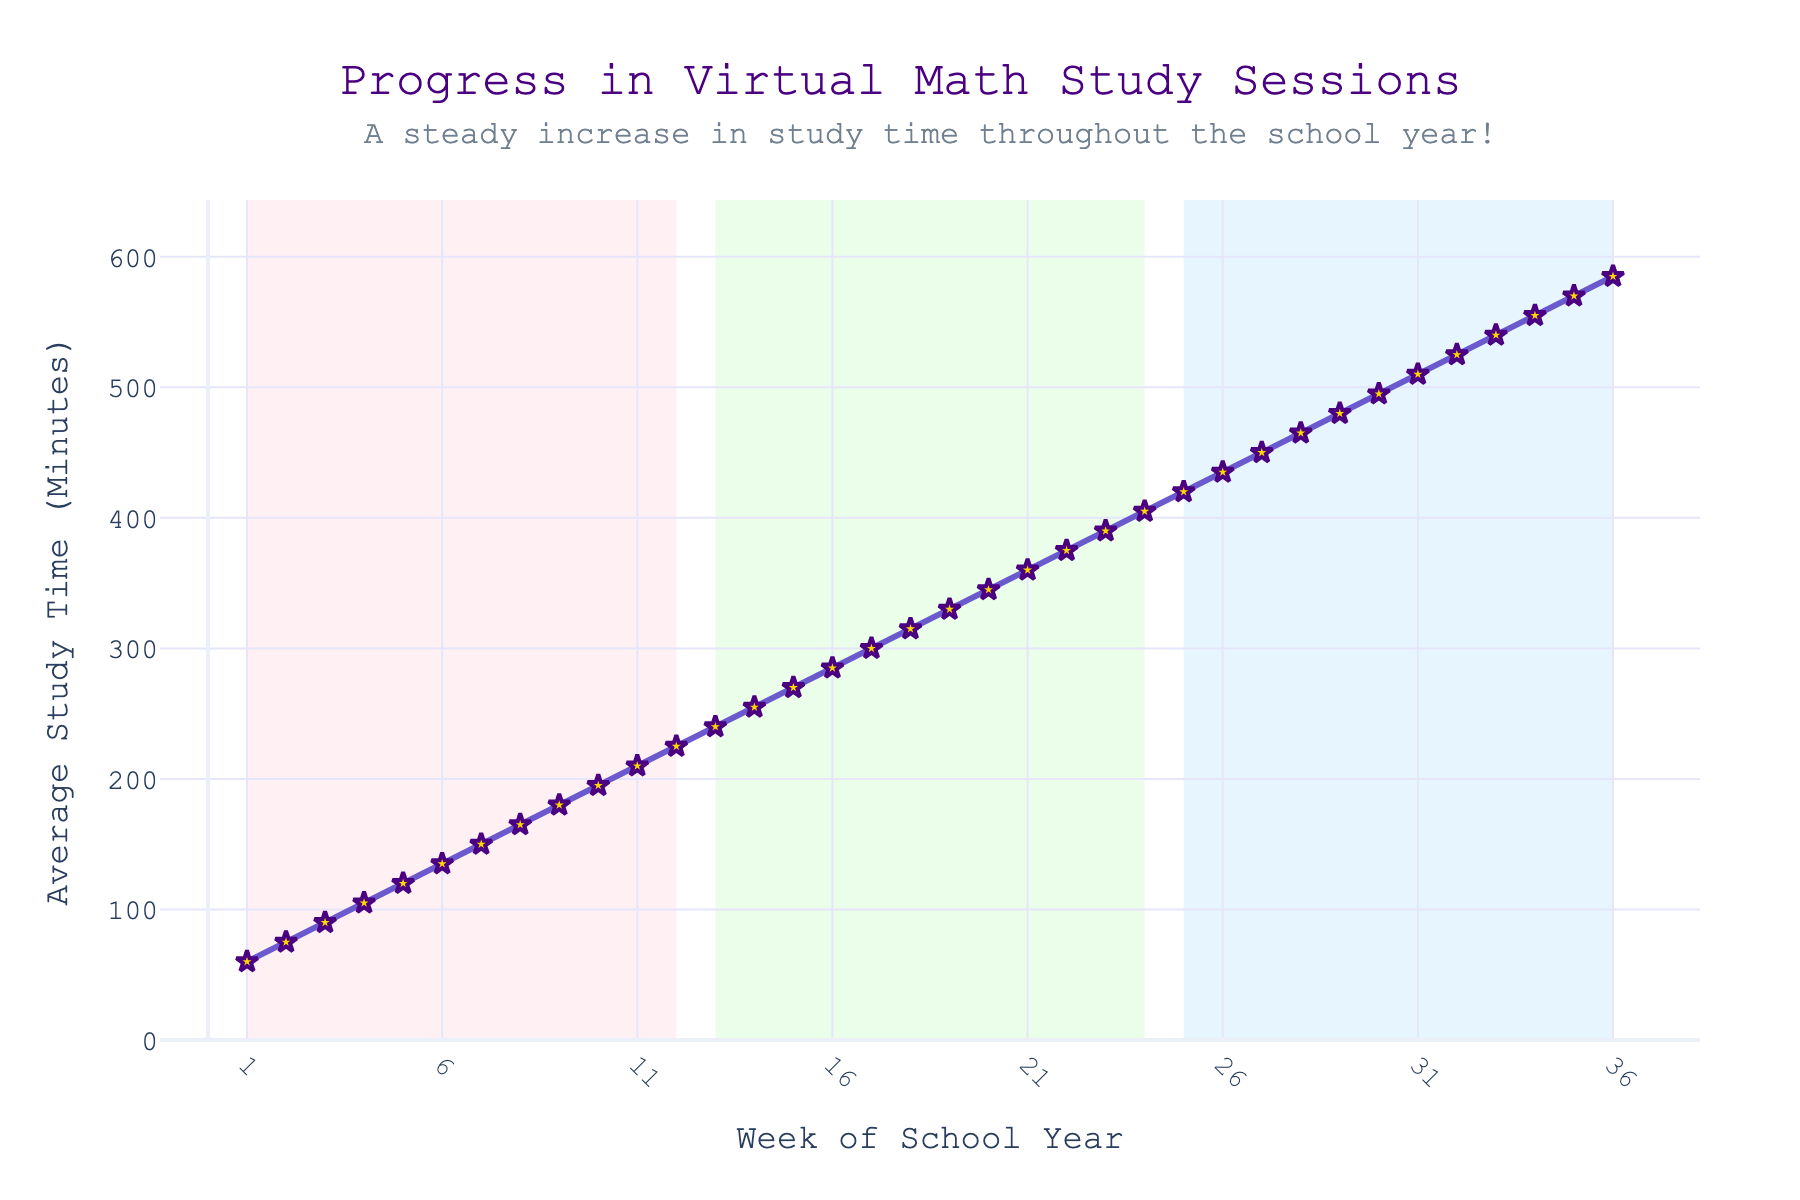How does the average study time change from Week 5 to Week 15? To find the change, subtract the average study time at Week 5 from the average study time at Week 15. The average study times are 120 minutes at Week 5 and 270 minutes at Week 15. The change is 270 - 120 = 150 minutes.
Answer: 150 minutes What is the average weekly increase in study time over the entire school year? To compute this, we need the total increase in study time and then divide by the number of weeks. The total increase is from 60 minutes (Week 1) to 585 minutes (Week 36), which is 585 - 60 = 525 minutes. The average weekly increase is 525 minutes / 35 weeks = 15 minutes/week.
Answer: 15 minutes/week Which period has the highest average study time: Weeks 1-12, Weeks 13-24, or Weeks 25-36? Calculate the average study time for each of these periods. Weeks 1-12: (60+75+90+105+120+135+150+165+180+195+210+225)/12 = 148.75 minutes; Weeks 13-24: (240+255+270+285+300+315+330+345+360+375+390+405)/12 = 317.5 minutes; Weeks 25-36: (420+435+450+465+480+495+510+525+540+555+570+585)/12 = 487.5 minutes. The highest average study time is in Weeks 25-36.
Answer: Weeks 25-36 Between which two consecutive weeks is the largest increase in average study time observed? To determine this, look at the changes between consecutive weeks. Calculate the differences: Week 2 - Week 1 = 15, Week 3 - Week 2 = 15, ..., Week 36 - Week 35 = 15. The differences are the same each week, so any consecutive weeks will have the same increase.
Answer: Any consecutive weeks Is the increase in average study time consistent throughout the school year? Based on the line chart, the increase appears to be consistent with the same slope throughout the school year, showing a steady, linear rise.
Answer: Yes In which portion of the school year (Weeks 1-12, Weeks 13-24, Weeks 25-36) is the study time increase the steepest? The rate of increase appears consistent throughout the chart, implying that the study time increase is even across all three portions when observed from the linear trend lines.
Answer: All portions equally What visual feature indicates the trend of average study time throughout the school year? The steady upward slope of the line and the star markers connected by lines indicate a consistent increase in average study time throughout the school year. The annotations and the line's color also help point out the trend.
Answer: steady upward slope How many weeks into the school year did the average study time exceed 300 minutes for the first time? Locate the point where the study time first exceeds 300 minutes. This happens at Week 17.
Answer: Week 17 Which week marks the halfway point of the data set and what is the average study time during that week? The data set has 36 weeks, so the halfway point is 36/2 = Week 18. At Week 18, the average study time is 315 minutes.
Answer: Week 18, 315 minutes What can be inferred from the shaded regions in the background of the chart? The shaded regions demarcate different parts of the school year: Weeks 1-12 (first part, shaded pink), Weeks 13-24 (second part, shaded green), Weeks 25-36 (final part, shaded blue), possibly highlighting different academic terms or periods.
Answer: Different parts of the school year, possibly academic terms 